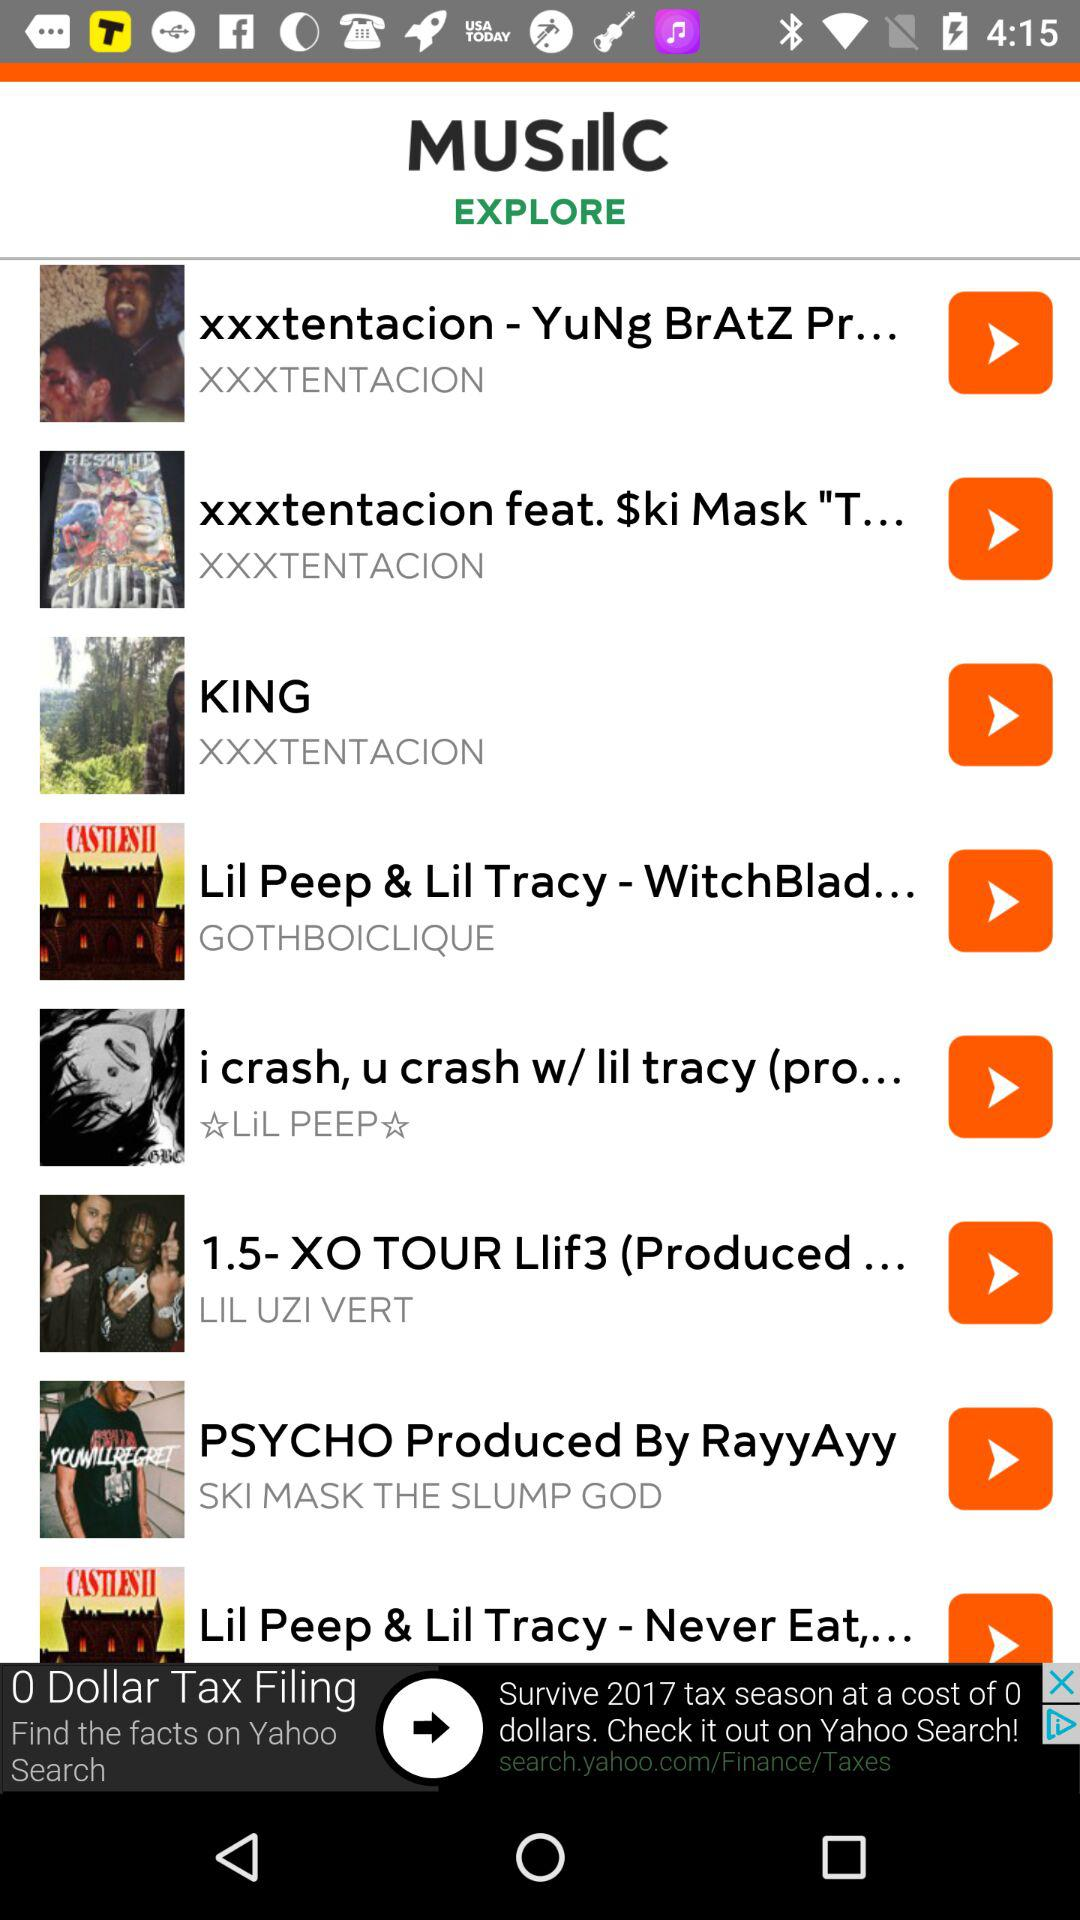Who produced the song "PSYCHO"? The song "PSYCHO" is produced by "RayyAyy". 